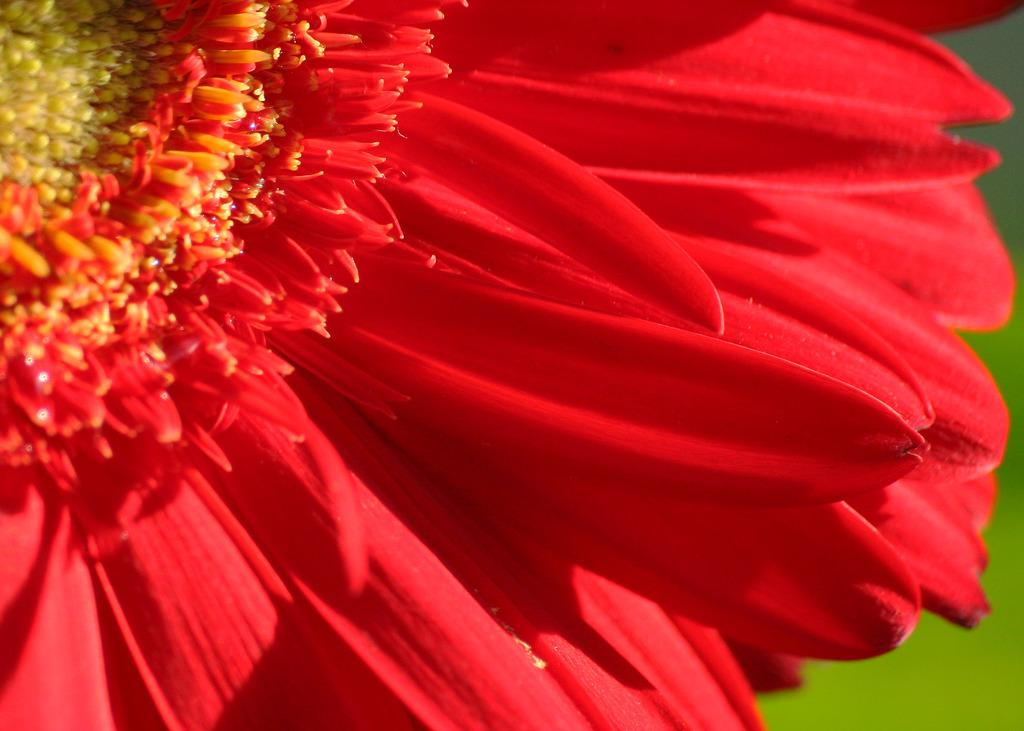What is the main subject of the image? The main subject of the image is a flower. What color is the flower? The flower is red. What type of metal can be seen in the image? There is no metal present in the image; it features a red flower. How many patches are visible on the flower in the image? There are no patches visible on the flower in the image, as it is a single red flower. 